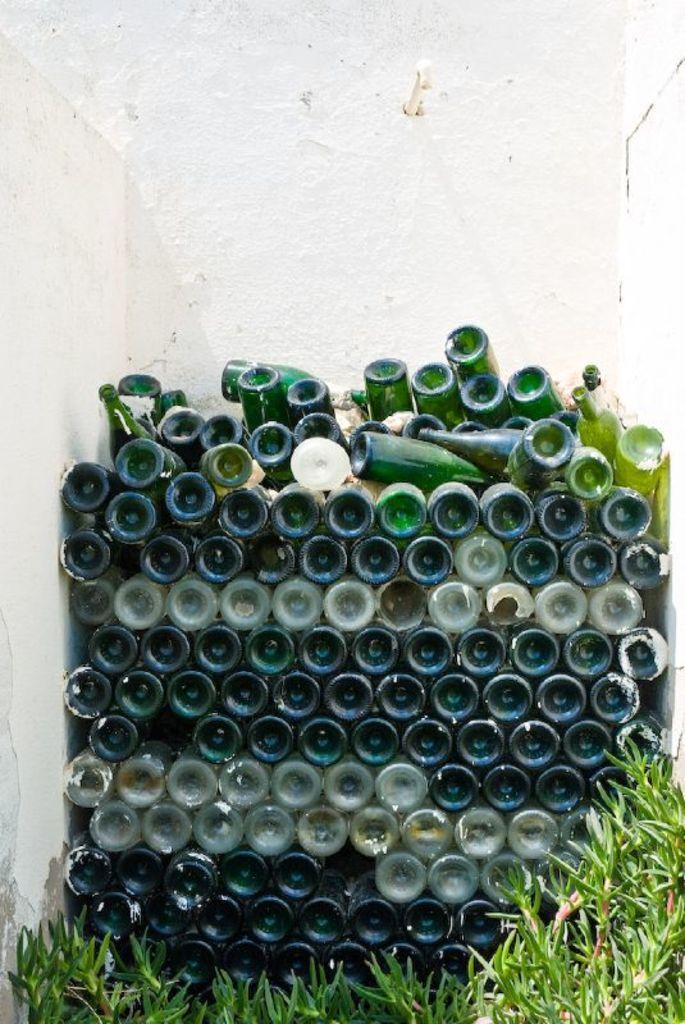What objects can be seen in the image? There are bottles in the image. Where are the bottles located? The bottles are on the land. What else is present near the bottles? There are plants near the bottles. How are the bottles arranged in the image? The bottles are stacked one on top of the other. What is close to the bottles in the image? The bottles are near a wall. What type of screw can be seen in the image? There is no screw present in the image. 